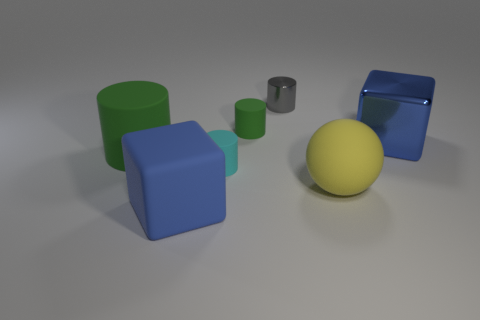Subtract all gray shiny cylinders. How many cylinders are left? 3 Add 2 small gray cubes. How many objects exist? 9 Subtract all cyan cylinders. How many cylinders are left? 3 Subtract all cyan spheres. How many green cylinders are left? 2 Subtract all balls. How many objects are left? 6 Subtract all small green things. Subtract all big blue metallic cubes. How many objects are left? 5 Add 7 small objects. How many small objects are left? 10 Add 6 tiny blue blocks. How many tiny blue blocks exist? 6 Subtract 0 blue spheres. How many objects are left? 7 Subtract 4 cylinders. How many cylinders are left? 0 